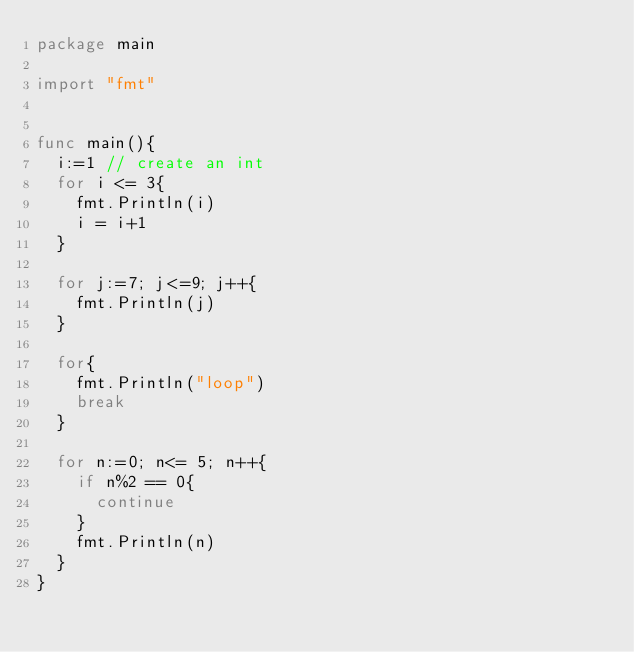<code> <loc_0><loc_0><loc_500><loc_500><_Go_>package main

import "fmt"


func main(){
	i:=1 // create an int
	for i <= 3{
		fmt.Println(i)
		i = i+1
	}

	for j:=7; j<=9; j++{
		fmt.Println(j)
	}

	for{
		fmt.Println("loop")
		break
	}

	for n:=0; n<= 5; n++{
		if n%2 == 0{
			continue
		}
		fmt.Println(n)
	}
}
</code> 